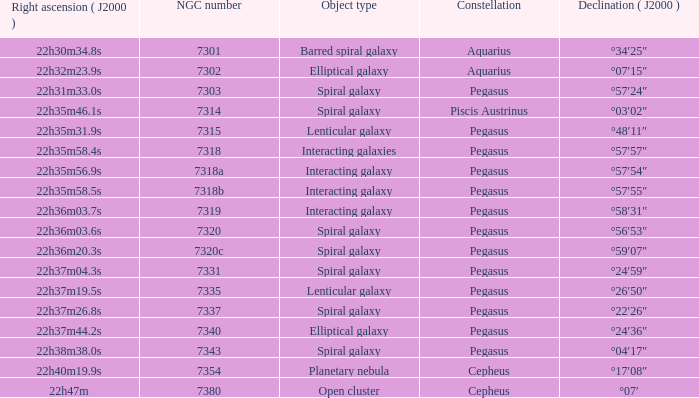What is the declination of the spiral galaxy Pegasus with 7337 NGC °22′26″. 